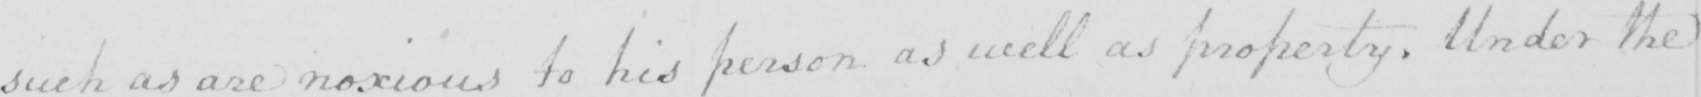Can you read and transcribe this handwriting? such as are noxious to his person as well as property . Under the 